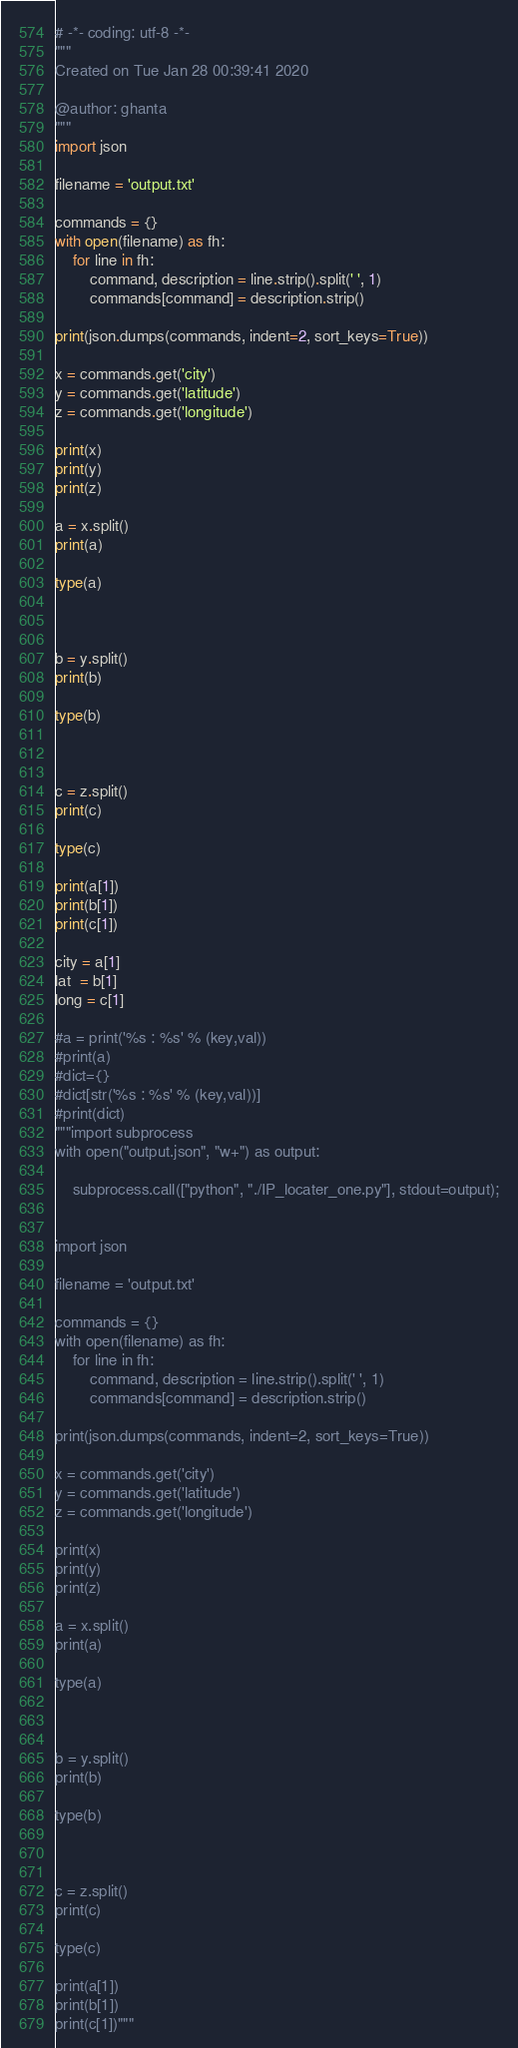<code> <loc_0><loc_0><loc_500><loc_500><_Python_># -*- coding: utf-8 -*-
"""
Created on Tue Jan 28 00:39:41 2020

@author: ghanta
"""
import json

filename = 'output.txt'

commands = {}
with open(filename) as fh:
    for line in fh:
        command, description = line.strip().split(' ', 1)
        commands[command] = description.strip()

print(json.dumps(commands, indent=2, sort_keys=True))

x = commands.get('city')
y = commands.get('latitude')
z = commands.get('longitude')

print(x)
print(y)
print(z)

a = x.split()
print(a)

type(a)



b = y.split()
print(b)

type(b)



c = z.split()
print(c)

type(c)

print(a[1])
print(b[1])
print(c[1])

city = a[1]
lat  = b[1]
long = c[1]

#a = print('%s : %s' % (key,val))
#print(a)
#dict={}
#dict[str('%s : %s' % (key,val))]
#print(dict)
"""import subprocess
with open("output.json", "w+") as output:
    
    subprocess.call(["python", "./IP_locater_one.py"], stdout=output);
    
    
import json

filename = 'output.txt'

commands = {}
with open(filename) as fh:
    for line in fh:
        command, description = line.strip().split(' ', 1)
        commands[command] = description.strip()

print(json.dumps(commands, indent=2, sort_keys=True))

x = commands.get('city')
y = commands.get('latitude')
z = commands.get('longitude')

print(x)
print(y)
print(z)

a = x.split()
print(a)

type(a)



b = y.split()
print(b)

type(b)



c = z.split()
print(c)

type(c)

print(a[1])
print(b[1])
print(c[1])"""</code> 